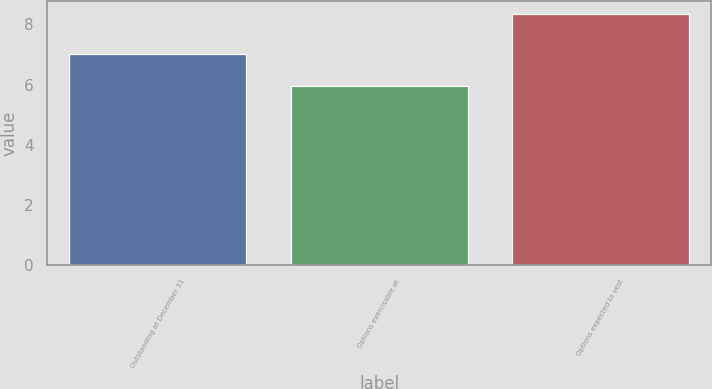<chart> <loc_0><loc_0><loc_500><loc_500><bar_chart><fcel>Outstanding at December 31<fcel>Options exercisable at<fcel>Options expected to vest<nl><fcel>7.03<fcel>5.97<fcel>8.36<nl></chart> 